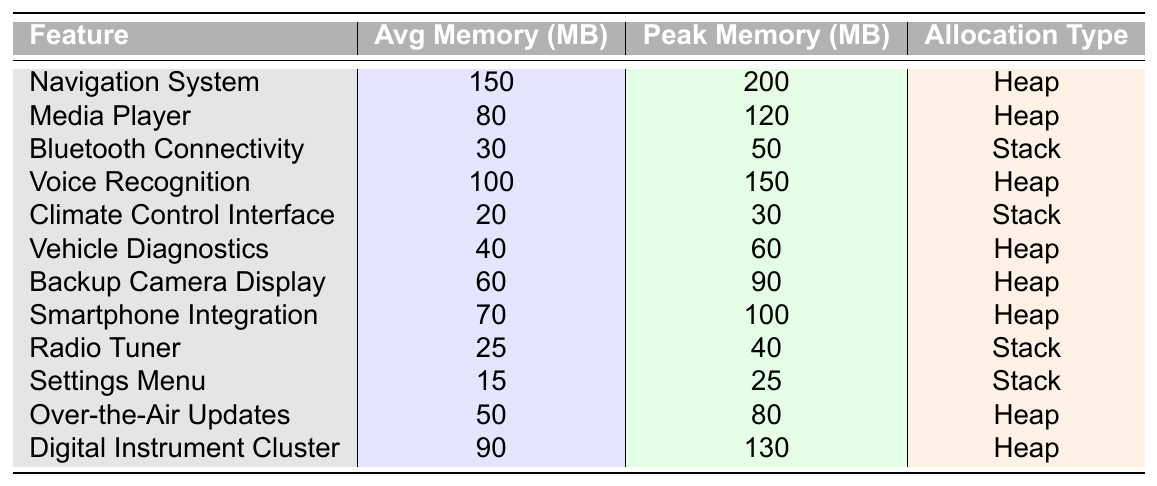What is the average memory usage of the Navigation System? According to the table, the average memory usage for the Navigation System is listed as 150 MB.
Answer: 150 MB Which feature has the highest peak memory usage? By examining the table, the Navigation System has the highest peak memory usage of 200 MB, compared to all other features.
Answer: Navigation System Is the Climate Control Interface memory allocation type Stack? Yes, the table explicitly states that the Climate Control Interface uses Stack as its memory allocation type.
Answer: Yes What is the difference between the average memory usage of the Media Player and the Voice Recognition feature? The average memory usage of the Media Player is 80 MB and the Voice Recognition feature is 100 MB. The difference is 100 - 80 = 20 MB.
Answer: 20 MB How much more average memory does the Digital Instrument Cluster use compared to the Settings Menu? The Digital Instrument Cluster uses an average of 90 MB and the Settings Menu uses 15 MB. The difference in average memory is 90 - 15 = 75 MB.
Answer: 75 MB What percentage of the peak memory usage does the average memory usage for the Backup Camera Display represent? The average memory usage for the Backup Camera Display is 60 MB, and its peak memory usage is 90 MB. To calculate the percentage: (60/90) * 100 = 66.67%.
Answer: 66.67% How many features use Heap as the memory allocation type? Looking at the table, the features using Heap are: Navigation System, Media Player, Voice Recognition, Vehicle Diagnostics, Backup Camera Display, Smartphone Integration, Over-the-Air Updates, and Digital Instrument Cluster, totaling 8 features.
Answer: 8 features Which feature has the lowest peak memory usage, and what is its value? Referring to the table, the Settings Menu has the lowest peak memory usage of 25 MB.
Answer: Settings Menu, 25 MB Does the average memory usage of Bluetooth Connectivity exceed 40 MB? No, the average memory usage of Bluetooth Connectivity is 30 MB, which does not exceed 40 MB.
Answer: No What is the total average memory usage of all features listed in the table? To find the total average memory usage, sum up all the average values: 150 + 80 + 30 + 100 + 20 + 40 + 60 + 70 + 25 + 15 + 50 + 90 = 800 MB.
Answer: 800 MB 